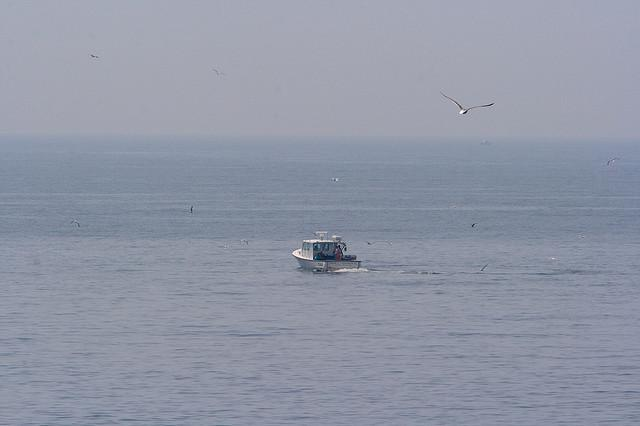What is the name of the object on top of the boat's roof? radar 